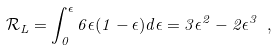Convert formula to latex. <formula><loc_0><loc_0><loc_500><loc_500>\mathcal { R } _ { L } = \int _ { 0 } ^ { \epsilon } 6 \epsilon ( 1 - \epsilon ) d \epsilon = 3 \epsilon ^ { 2 } - 2 \epsilon ^ { 3 } \ ,</formula> 